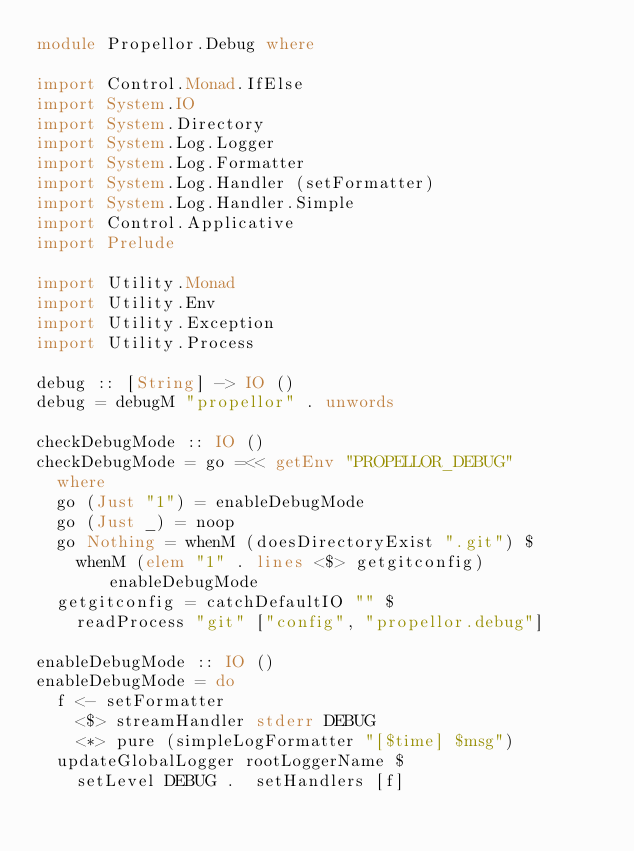<code> <loc_0><loc_0><loc_500><loc_500><_Haskell_>module Propellor.Debug where

import Control.Monad.IfElse
import System.IO
import System.Directory
import System.Log.Logger
import System.Log.Formatter
import System.Log.Handler (setFormatter)
import System.Log.Handler.Simple
import Control.Applicative
import Prelude

import Utility.Monad
import Utility.Env
import Utility.Exception
import Utility.Process

debug :: [String] -> IO ()
debug = debugM "propellor" . unwords

checkDebugMode :: IO ()
checkDebugMode = go =<< getEnv "PROPELLOR_DEBUG"
  where
	go (Just "1") = enableDebugMode
	go (Just _) = noop
	go Nothing = whenM (doesDirectoryExist ".git") $
		whenM (elem "1" . lines <$> getgitconfig) enableDebugMode
	getgitconfig = catchDefaultIO "" $
		readProcess "git" ["config", "propellor.debug"]

enableDebugMode :: IO ()
enableDebugMode = do
	f <- setFormatter
		<$> streamHandler stderr DEBUG
		<*> pure (simpleLogFormatter "[$time] $msg")
	updateGlobalLogger rootLoggerName $ 
		setLevel DEBUG .  setHandlers [f]
</code> 